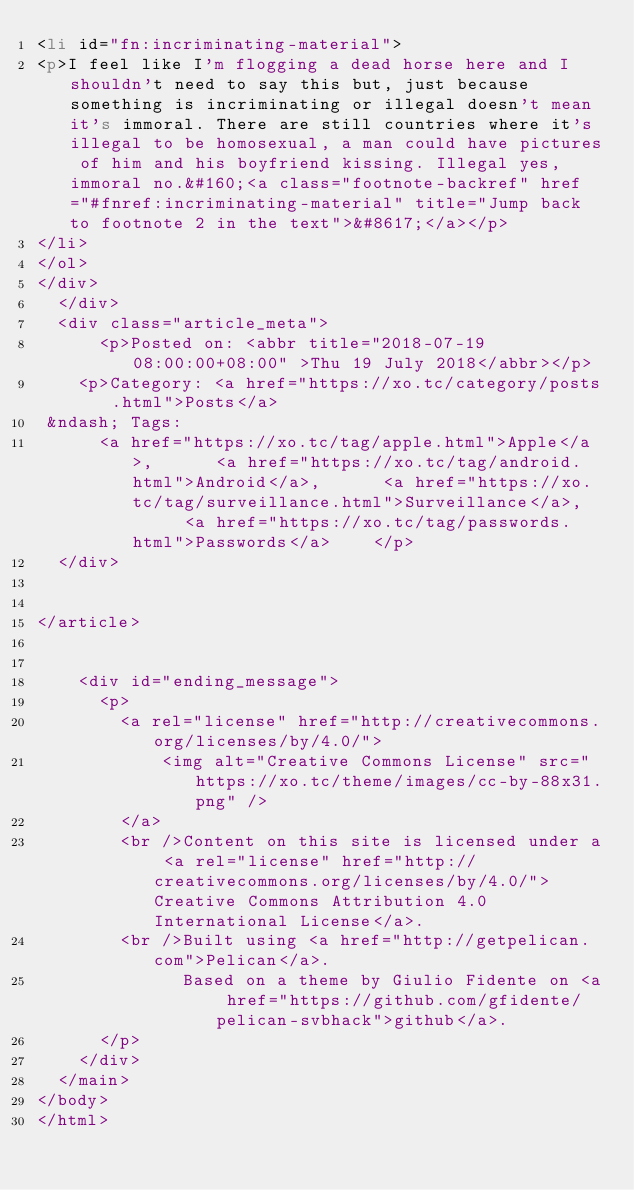Convert code to text. <code><loc_0><loc_0><loc_500><loc_500><_HTML_><li id="fn:incriminating-material">
<p>I feel like I'm flogging a dead horse here and I shouldn't need to say this but, just because something is incriminating or illegal doesn't mean it's immoral. There are still countries where it's illegal to be homosexual, a man could have pictures of him and his boyfriend kissing. Illegal yes, immoral no.&#160;<a class="footnote-backref" href="#fnref:incriminating-material" title="Jump back to footnote 2 in the text">&#8617;</a></p>
</li>
</ol>
</div>
  </div>
  <div class="article_meta">
      <p>Posted on: <abbr title="2018-07-19 08:00:00+08:00" >Thu 19 July 2018</abbr></p>
    <p>Category: <a href="https://xo.tc/category/posts.html">Posts</a>
 &ndash; Tags:
      <a href="https://xo.tc/tag/apple.html">Apple</a>,      <a href="https://xo.tc/tag/android.html">Android</a>,      <a href="https://xo.tc/tag/surveillance.html">Surveillance</a>,      <a href="https://xo.tc/tag/passwords.html">Passwords</a>    </p>
  </div>


</article>


    <div id="ending_message">
      <p>
        <a rel="license" href="http://creativecommons.org/licenses/by/4.0/">
            <img alt="Creative Commons License" src="https://xo.tc/theme/images/cc-by-88x31.png" />
        </a>
        <br />Content on this site is licensed under a <a rel="license" href="http://creativecommons.org/licenses/by/4.0/">Creative Commons Attribution 4.0 International License</a>.
        <br />Built using <a href="http://getpelican.com">Pelican</a>.
              Based on a theme by Giulio Fidente on <a href="https://github.com/gfidente/pelican-svbhack">github</a>.
      </p>
    </div>
  </main>
</body>
</html></code> 